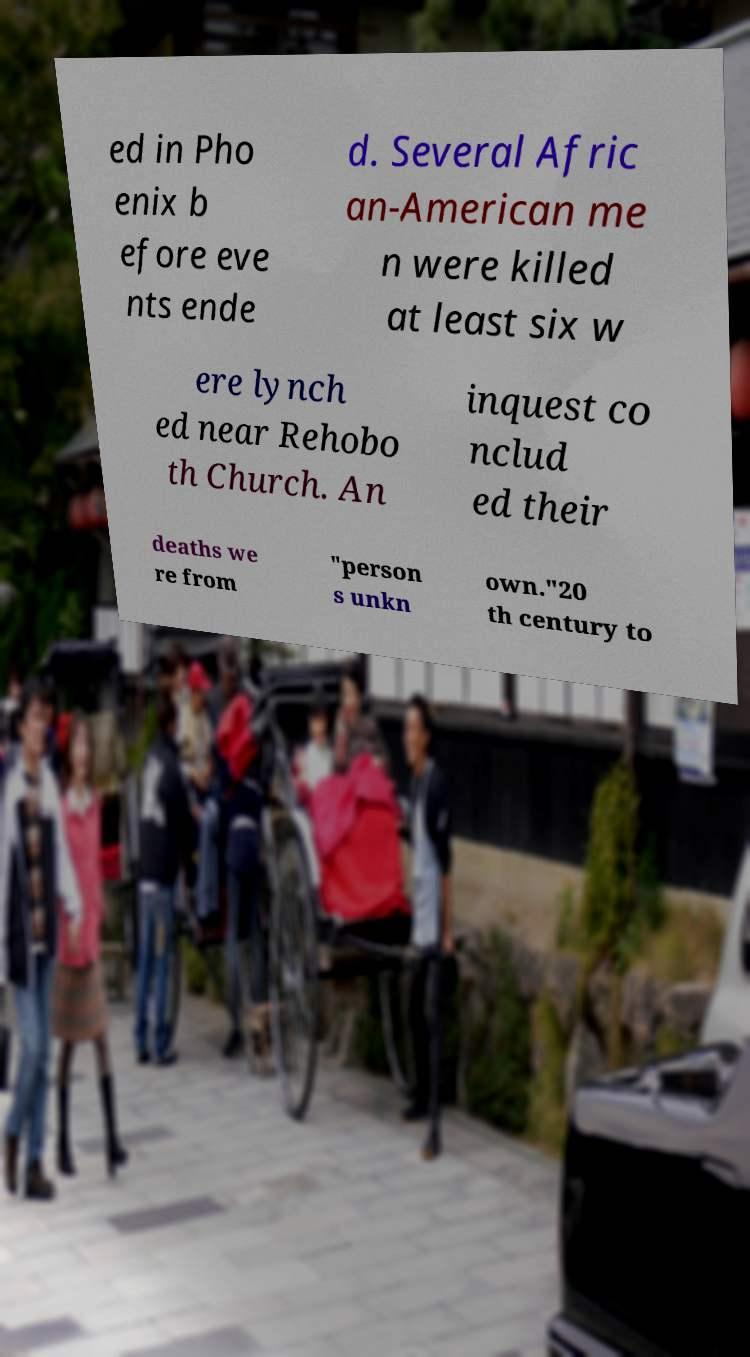Can you read and provide the text displayed in the image?This photo seems to have some interesting text. Can you extract and type it out for me? ed in Pho enix b efore eve nts ende d. Several Afric an-American me n were killed at least six w ere lynch ed near Rehobo th Church. An inquest co nclud ed their deaths we re from "person s unkn own."20 th century to 